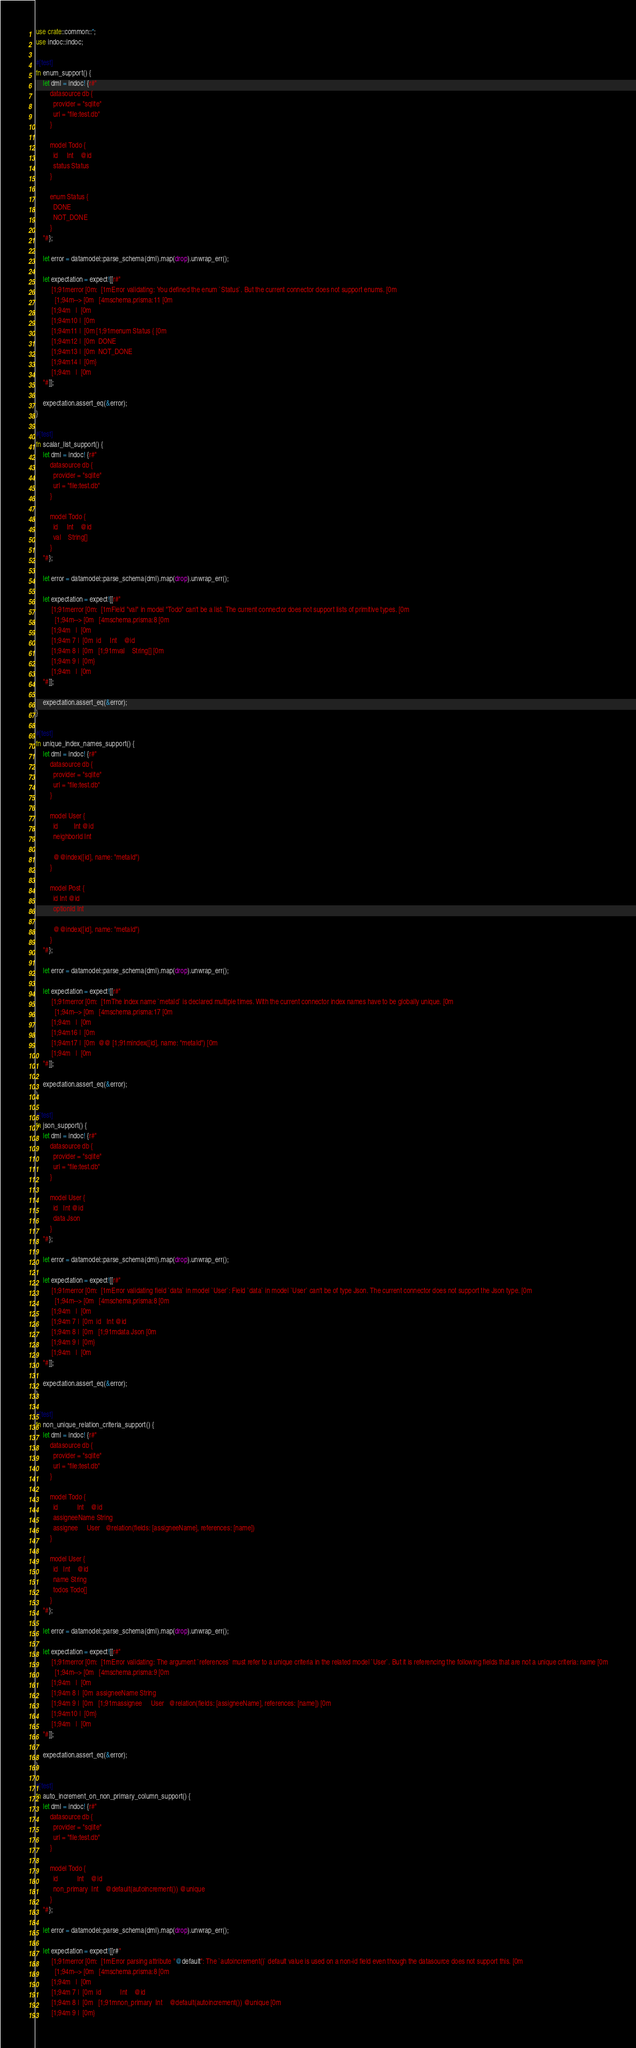Convert code to text. <code><loc_0><loc_0><loc_500><loc_500><_Rust_>use crate::common::*;
use indoc::indoc;

#[test]
fn enum_support() {
    let dml = indoc! {r#"
        datasource db {
          provider = "sqlite"
          url = "file:test.db"
        }

        model Todo {
          id     Int    @id
          status Status
        }

        enum Status {
          DONE
          NOT_DONE
        }
    "#};

    let error = datamodel::parse_schema(dml).map(drop).unwrap_err();

    let expectation = expect![[r#"
        [1;91merror[0m: [1mError validating: You defined the enum `Status`. But the current connector does not support enums.[0m
          [1;94m-->[0m  [4mschema.prisma:11[0m
        [1;94m   | [0m
        [1;94m10 | [0m
        [1;94m11 | [0m[1;91menum Status {[0m
        [1;94m12 | [0m  DONE
        [1;94m13 | [0m  NOT_DONE
        [1;94m14 | [0m}
        [1;94m   | [0m
    "#]];

    expectation.assert_eq(&error);
}

#[test]
fn scalar_list_support() {
    let dml = indoc! {r#"
        datasource db {
          provider = "sqlite"
          url = "file:test.db"
        }

        model Todo {
          id     Int    @id
          val    String[]
        }
    "#};

    let error = datamodel::parse_schema(dml).map(drop).unwrap_err();

    let expectation = expect![[r#"
        [1;91merror[0m: [1mField "val" in model "Todo" can't be a list. The current connector does not support lists of primitive types.[0m
          [1;94m-->[0m  [4mschema.prisma:8[0m
        [1;94m   | [0m
        [1;94m 7 | [0m  id     Int    @id
        [1;94m 8 | [0m  [1;91mval    String[][0m
        [1;94m 9 | [0m}
        [1;94m   | [0m
    "#]];

    expectation.assert_eq(&error);
}

#[test]
fn unique_index_names_support() {
    let dml = indoc! {r#"
        datasource db {
          provider = "sqlite"
          url = "file:test.db"
        }

        model User {
          id         Int @id
          neighborId Int

          @@index([id], name: "metaId")
        }

        model Post {
          id Int @id
          optionId Int

          @@index([id], name: "metaId")
        }
    "#};

    let error = datamodel::parse_schema(dml).map(drop).unwrap_err();

    let expectation = expect![[r#"
        [1;91merror[0m: [1mThe index name `metaId` is declared multiple times. With the current connector index names have to be globally unique.[0m
          [1;94m-->[0m  [4mschema.prisma:17[0m
        [1;94m   | [0m
        [1;94m16 | [0m
        [1;94m17 | [0m  @@[1;91mindex([id], name: "metaId")[0m
        [1;94m   | [0m
    "#]];

    expectation.assert_eq(&error);
}

#[test]
fn json_support() {
    let dml = indoc! {r#"
        datasource db {
          provider = "sqlite"
          url = "file:test.db"
        }

        model User {
          id   Int @id
          data Json
        }
    "#};

    let error = datamodel::parse_schema(dml).map(drop).unwrap_err();

    let expectation = expect![[r#"
        [1;91merror[0m: [1mError validating field `data` in model `User`: Field `data` in model `User` can't be of type Json. The current connector does not support the Json type.[0m
          [1;94m-->[0m  [4mschema.prisma:8[0m
        [1;94m   | [0m
        [1;94m 7 | [0m  id   Int @id
        [1;94m 8 | [0m  [1;91mdata Json[0m
        [1;94m 9 | [0m}
        [1;94m   | [0m
    "#]];

    expectation.assert_eq(&error);
}

#[test]
fn non_unique_relation_criteria_support() {
    let dml = indoc! {r#"
        datasource db {
          provider = "sqlite"
          url = "file:test.db"
        }

        model Todo {
          id           Int    @id
          assigneeName String
          assignee     User   @relation(fields: [assigneeName], references: [name])
        }

        model User {
          id   Int    @id
          name String
          todos Todo[]
        }
    "#};

    let error = datamodel::parse_schema(dml).map(drop).unwrap_err();

    let expectation = expect![[r#"
        [1;91merror[0m: [1mError validating: The argument `references` must refer to a unique criteria in the related model `User`. But it is referencing the following fields that are not a unique criteria: name[0m
          [1;94m-->[0m  [4mschema.prisma:9[0m
        [1;94m   | [0m
        [1;94m 8 | [0m  assigneeName String
        [1;94m 9 | [0m  [1;91massignee     User   @relation(fields: [assigneeName], references: [name])[0m
        [1;94m10 | [0m}
        [1;94m   | [0m
    "#]];

    expectation.assert_eq(&error);
}

#[test]
fn auto_increment_on_non_primary_column_support() {
    let dml = indoc! {r#"
        datasource db {
          provider = "sqlite"
          url = "file:test.db"
        }

        model Todo {
          id           Int    @id
          non_primary  Int    @default(autoincrement()) @unique
        }
    "#};

    let error = datamodel::parse_schema(dml).map(drop).unwrap_err();

    let expectation = expect![[r#"
        [1;91merror[0m: [1mError parsing attribute "@default": The `autoincrement()` default value is used on a non-id field even though the datasource does not support this.[0m
          [1;94m-->[0m  [4mschema.prisma:8[0m
        [1;94m   | [0m
        [1;94m 7 | [0m  id           Int    @id
        [1;94m 8 | [0m  [1;91mnon_primary  Int    @default(autoincrement()) @unique[0m
        [1;94m 9 | [0m}</code> 